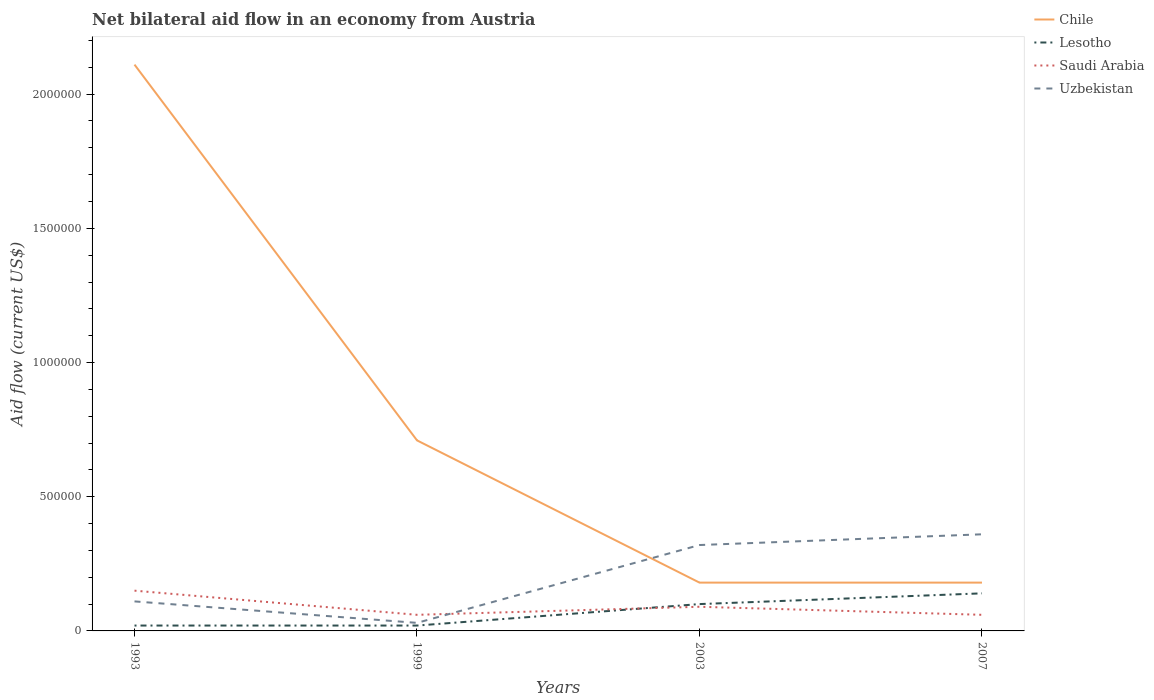Is the number of lines equal to the number of legend labels?
Ensure brevity in your answer.  Yes. Across all years, what is the maximum net bilateral aid flow in Saudi Arabia?
Give a very brief answer. 6.00e+04. What is the difference between the highest and the second highest net bilateral aid flow in Chile?
Ensure brevity in your answer.  1.93e+06. What is the difference between two consecutive major ticks on the Y-axis?
Provide a short and direct response. 5.00e+05. Does the graph contain grids?
Your answer should be compact. No. Where does the legend appear in the graph?
Offer a terse response. Top right. How many legend labels are there?
Your answer should be very brief. 4. What is the title of the graph?
Keep it short and to the point. Net bilateral aid flow in an economy from Austria. Does "Nepal" appear as one of the legend labels in the graph?
Your answer should be very brief. No. What is the label or title of the Y-axis?
Provide a succinct answer. Aid flow (current US$). What is the Aid flow (current US$) in Chile in 1993?
Give a very brief answer. 2.11e+06. What is the Aid flow (current US$) in Lesotho in 1993?
Provide a short and direct response. 2.00e+04. What is the Aid flow (current US$) of Saudi Arabia in 1993?
Provide a short and direct response. 1.50e+05. What is the Aid flow (current US$) in Uzbekistan in 1993?
Make the answer very short. 1.10e+05. What is the Aid flow (current US$) of Chile in 1999?
Your answer should be very brief. 7.10e+05. What is the Aid flow (current US$) in Uzbekistan in 1999?
Keep it short and to the point. 3.00e+04. What is the Aid flow (current US$) in Chile in 2007?
Ensure brevity in your answer.  1.80e+05. What is the Aid flow (current US$) of Uzbekistan in 2007?
Offer a terse response. 3.60e+05. Across all years, what is the maximum Aid flow (current US$) of Chile?
Offer a terse response. 2.11e+06. Across all years, what is the maximum Aid flow (current US$) in Lesotho?
Provide a succinct answer. 1.40e+05. Across all years, what is the maximum Aid flow (current US$) of Saudi Arabia?
Keep it short and to the point. 1.50e+05. Across all years, what is the maximum Aid flow (current US$) in Uzbekistan?
Provide a succinct answer. 3.60e+05. Across all years, what is the minimum Aid flow (current US$) in Chile?
Offer a terse response. 1.80e+05. Across all years, what is the minimum Aid flow (current US$) of Lesotho?
Your response must be concise. 2.00e+04. Across all years, what is the minimum Aid flow (current US$) of Saudi Arabia?
Make the answer very short. 6.00e+04. Across all years, what is the minimum Aid flow (current US$) in Uzbekistan?
Provide a short and direct response. 3.00e+04. What is the total Aid flow (current US$) in Chile in the graph?
Ensure brevity in your answer.  3.18e+06. What is the total Aid flow (current US$) of Lesotho in the graph?
Make the answer very short. 2.80e+05. What is the total Aid flow (current US$) of Saudi Arabia in the graph?
Offer a very short reply. 3.60e+05. What is the total Aid flow (current US$) of Uzbekistan in the graph?
Your response must be concise. 8.20e+05. What is the difference between the Aid flow (current US$) of Chile in 1993 and that in 1999?
Keep it short and to the point. 1.40e+06. What is the difference between the Aid flow (current US$) of Saudi Arabia in 1993 and that in 1999?
Your answer should be compact. 9.00e+04. What is the difference between the Aid flow (current US$) of Chile in 1993 and that in 2003?
Ensure brevity in your answer.  1.93e+06. What is the difference between the Aid flow (current US$) in Saudi Arabia in 1993 and that in 2003?
Your response must be concise. 6.00e+04. What is the difference between the Aid flow (current US$) in Chile in 1993 and that in 2007?
Offer a very short reply. 1.93e+06. What is the difference between the Aid flow (current US$) of Chile in 1999 and that in 2003?
Provide a short and direct response. 5.30e+05. What is the difference between the Aid flow (current US$) in Saudi Arabia in 1999 and that in 2003?
Your response must be concise. -3.00e+04. What is the difference between the Aid flow (current US$) of Uzbekistan in 1999 and that in 2003?
Give a very brief answer. -2.90e+05. What is the difference between the Aid flow (current US$) of Chile in 1999 and that in 2007?
Ensure brevity in your answer.  5.30e+05. What is the difference between the Aid flow (current US$) of Uzbekistan in 1999 and that in 2007?
Offer a terse response. -3.30e+05. What is the difference between the Aid flow (current US$) in Saudi Arabia in 2003 and that in 2007?
Make the answer very short. 3.00e+04. What is the difference between the Aid flow (current US$) of Chile in 1993 and the Aid flow (current US$) of Lesotho in 1999?
Provide a succinct answer. 2.09e+06. What is the difference between the Aid flow (current US$) in Chile in 1993 and the Aid flow (current US$) in Saudi Arabia in 1999?
Make the answer very short. 2.05e+06. What is the difference between the Aid flow (current US$) of Chile in 1993 and the Aid flow (current US$) of Uzbekistan in 1999?
Give a very brief answer. 2.08e+06. What is the difference between the Aid flow (current US$) of Lesotho in 1993 and the Aid flow (current US$) of Uzbekistan in 1999?
Your answer should be compact. -10000. What is the difference between the Aid flow (current US$) in Saudi Arabia in 1993 and the Aid flow (current US$) in Uzbekistan in 1999?
Provide a short and direct response. 1.20e+05. What is the difference between the Aid flow (current US$) in Chile in 1993 and the Aid flow (current US$) in Lesotho in 2003?
Keep it short and to the point. 2.01e+06. What is the difference between the Aid flow (current US$) of Chile in 1993 and the Aid flow (current US$) of Saudi Arabia in 2003?
Make the answer very short. 2.02e+06. What is the difference between the Aid flow (current US$) in Chile in 1993 and the Aid flow (current US$) in Uzbekistan in 2003?
Offer a terse response. 1.79e+06. What is the difference between the Aid flow (current US$) in Chile in 1993 and the Aid flow (current US$) in Lesotho in 2007?
Give a very brief answer. 1.97e+06. What is the difference between the Aid flow (current US$) of Chile in 1993 and the Aid flow (current US$) of Saudi Arabia in 2007?
Your answer should be compact. 2.05e+06. What is the difference between the Aid flow (current US$) of Chile in 1993 and the Aid flow (current US$) of Uzbekistan in 2007?
Offer a terse response. 1.75e+06. What is the difference between the Aid flow (current US$) of Lesotho in 1993 and the Aid flow (current US$) of Saudi Arabia in 2007?
Keep it short and to the point. -4.00e+04. What is the difference between the Aid flow (current US$) of Lesotho in 1993 and the Aid flow (current US$) of Uzbekistan in 2007?
Ensure brevity in your answer.  -3.40e+05. What is the difference between the Aid flow (current US$) in Chile in 1999 and the Aid flow (current US$) in Saudi Arabia in 2003?
Give a very brief answer. 6.20e+05. What is the difference between the Aid flow (current US$) of Chile in 1999 and the Aid flow (current US$) of Uzbekistan in 2003?
Keep it short and to the point. 3.90e+05. What is the difference between the Aid flow (current US$) of Lesotho in 1999 and the Aid flow (current US$) of Uzbekistan in 2003?
Ensure brevity in your answer.  -3.00e+05. What is the difference between the Aid flow (current US$) of Chile in 1999 and the Aid flow (current US$) of Lesotho in 2007?
Ensure brevity in your answer.  5.70e+05. What is the difference between the Aid flow (current US$) in Chile in 1999 and the Aid flow (current US$) in Saudi Arabia in 2007?
Keep it short and to the point. 6.50e+05. What is the difference between the Aid flow (current US$) in Lesotho in 1999 and the Aid flow (current US$) in Saudi Arabia in 2007?
Ensure brevity in your answer.  -4.00e+04. What is the difference between the Aid flow (current US$) of Lesotho in 1999 and the Aid flow (current US$) of Uzbekistan in 2007?
Ensure brevity in your answer.  -3.40e+05. What is the difference between the Aid flow (current US$) of Chile in 2003 and the Aid flow (current US$) of Lesotho in 2007?
Provide a succinct answer. 4.00e+04. What is the difference between the Aid flow (current US$) of Chile in 2003 and the Aid flow (current US$) of Uzbekistan in 2007?
Provide a short and direct response. -1.80e+05. What is the difference between the Aid flow (current US$) of Lesotho in 2003 and the Aid flow (current US$) of Uzbekistan in 2007?
Ensure brevity in your answer.  -2.60e+05. What is the average Aid flow (current US$) of Chile per year?
Your response must be concise. 7.95e+05. What is the average Aid flow (current US$) of Saudi Arabia per year?
Your response must be concise. 9.00e+04. What is the average Aid flow (current US$) in Uzbekistan per year?
Your response must be concise. 2.05e+05. In the year 1993, what is the difference between the Aid flow (current US$) of Chile and Aid flow (current US$) of Lesotho?
Your response must be concise. 2.09e+06. In the year 1993, what is the difference between the Aid flow (current US$) in Chile and Aid flow (current US$) in Saudi Arabia?
Your response must be concise. 1.96e+06. In the year 1993, what is the difference between the Aid flow (current US$) in Chile and Aid flow (current US$) in Uzbekistan?
Offer a very short reply. 2.00e+06. In the year 1993, what is the difference between the Aid flow (current US$) in Saudi Arabia and Aid flow (current US$) in Uzbekistan?
Make the answer very short. 4.00e+04. In the year 1999, what is the difference between the Aid flow (current US$) of Chile and Aid flow (current US$) of Lesotho?
Give a very brief answer. 6.90e+05. In the year 1999, what is the difference between the Aid flow (current US$) of Chile and Aid flow (current US$) of Saudi Arabia?
Ensure brevity in your answer.  6.50e+05. In the year 1999, what is the difference between the Aid flow (current US$) in Chile and Aid flow (current US$) in Uzbekistan?
Keep it short and to the point. 6.80e+05. In the year 1999, what is the difference between the Aid flow (current US$) of Lesotho and Aid flow (current US$) of Saudi Arabia?
Provide a succinct answer. -4.00e+04. In the year 2003, what is the difference between the Aid flow (current US$) in Chile and Aid flow (current US$) in Lesotho?
Offer a very short reply. 8.00e+04. In the year 2003, what is the difference between the Aid flow (current US$) in Chile and Aid flow (current US$) in Saudi Arabia?
Provide a short and direct response. 9.00e+04. In the year 2003, what is the difference between the Aid flow (current US$) in Chile and Aid flow (current US$) in Uzbekistan?
Provide a succinct answer. -1.40e+05. In the year 2003, what is the difference between the Aid flow (current US$) in Lesotho and Aid flow (current US$) in Saudi Arabia?
Keep it short and to the point. 10000. In the year 2003, what is the difference between the Aid flow (current US$) of Lesotho and Aid flow (current US$) of Uzbekistan?
Ensure brevity in your answer.  -2.20e+05. In the year 2003, what is the difference between the Aid flow (current US$) in Saudi Arabia and Aid flow (current US$) in Uzbekistan?
Provide a short and direct response. -2.30e+05. In the year 2007, what is the difference between the Aid flow (current US$) of Chile and Aid flow (current US$) of Lesotho?
Provide a succinct answer. 4.00e+04. In the year 2007, what is the difference between the Aid flow (current US$) in Lesotho and Aid flow (current US$) in Saudi Arabia?
Offer a very short reply. 8.00e+04. In the year 2007, what is the difference between the Aid flow (current US$) of Lesotho and Aid flow (current US$) of Uzbekistan?
Ensure brevity in your answer.  -2.20e+05. In the year 2007, what is the difference between the Aid flow (current US$) of Saudi Arabia and Aid flow (current US$) of Uzbekistan?
Keep it short and to the point. -3.00e+05. What is the ratio of the Aid flow (current US$) of Chile in 1993 to that in 1999?
Offer a very short reply. 2.97. What is the ratio of the Aid flow (current US$) in Lesotho in 1993 to that in 1999?
Your response must be concise. 1. What is the ratio of the Aid flow (current US$) in Uzbekistan in 1993 to that in 1999?
Make the answer very short. 3.67. What is the ratio of the Aid flow (current US$) in Chile in 1993 to that in 2003?
Your answer should be compact. 11.72. What is the ratio of the Aid flow (current US$) of Saudi Arabia in 1993 to that in 2003?
Your answer should be compact. 1.67. What is the ratio of the Aid flow (current US$) in Uzbekistan in 1993 to that in 2003?
Your answer should be very brief. 0.34. What is the ratio of the Aid flow (current US$) in Chile in 1993 to that in 2007?
Offer a very short reply. 11.72. What is the ratio of the Aid flow (current US$) in Lesotho in 1993 to that in 2007?
Offer a very short reply. 0.14. What is the ratio of the Aid flow (current US$) of Uzbekistan in 1993 to that in 2007?
Provide a succinct answer. 0.31. What is the ratio of the Aid flow (current US$) of Chile in 1999 to that in 2003?
Your answer should be compact. 3.94. What is the ratio of the Aid flow (current US$) in Lesotho in 1999 to that in 2003?
Offer a terse response. 0.2. What is the ratio of the Aid flow (current US$) of Uzbekistan in 1999 to that in 2003?
Offer a terse response. 0.09. What is the ratio of the Aid flow (current US$) in Chile in 1999 to that in 2007?
Keep it short and to the point. 3.94. What is the ratio of the Aid flow (current US$) in Lesotho in 1999 to that in 2007?
Make the answer very short. 0.14. What is the ratio of the Aid flow (current US$) of Saudi Arabia in 1999 to that in 2007?
Ensure brevity in your answer.  1. What is the ratio of the Aid flow (current US$) in Uzbekistan in 1999 to that in 2007?
Offer a very short reply. 0.08. What is the ratio of the Aid flow (current US$) in Uzbekistan in 2003 to that in 2007?
Your response must be concise. 0.89. What is the difference between the highest and the second highest Aid flow (current US$) in Chile?
Keep it short and to the point. 1.40e+06. What is the difference between the highest and the lowest Aid flow (current US$) of Chile?
Give a very brief answer. 1.93e+06. What is the difference between the highest and the lowest Aid flow (current US$) in Uzbekistan?
Keep it short and to the point. 3.30e+05. 